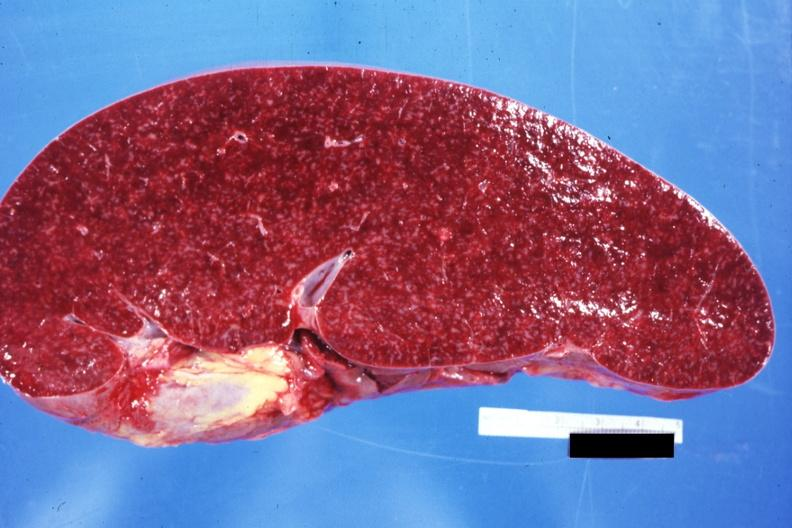does size appear normal see other sides this case?
Answer the question using a single word or phrase. Yes 